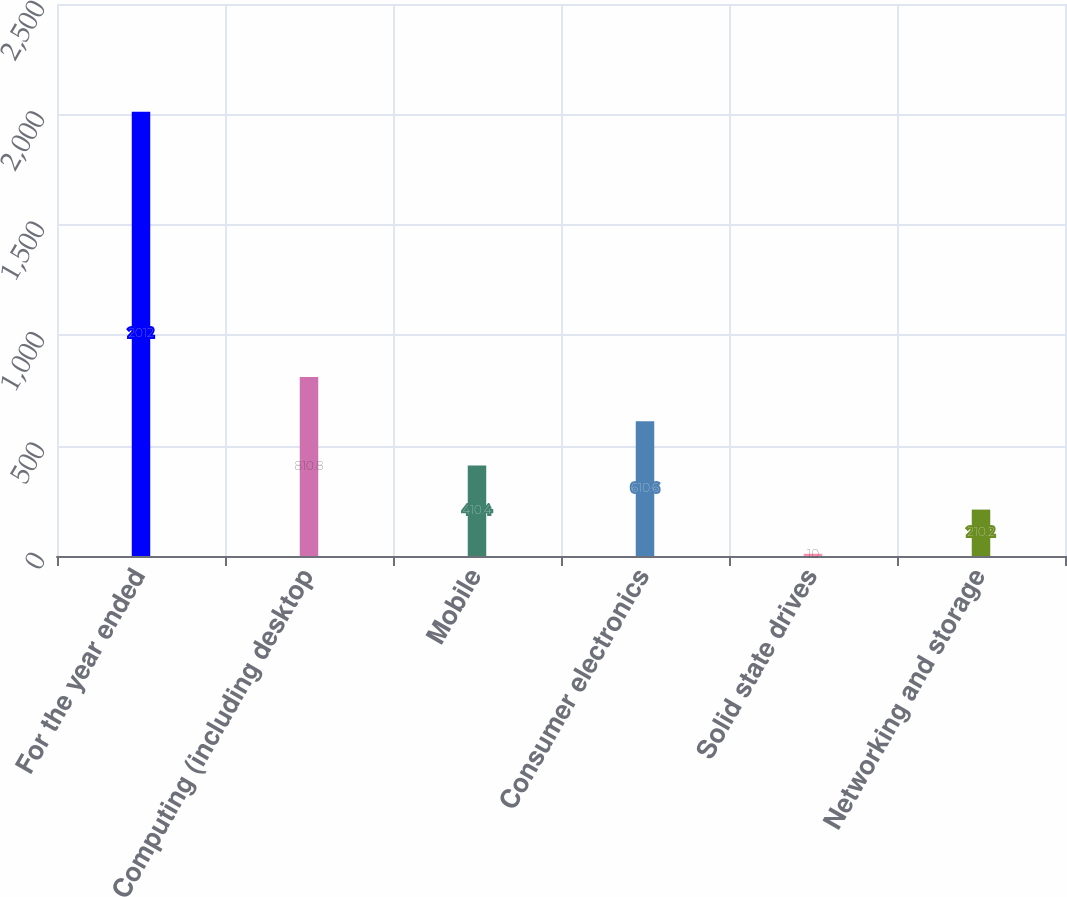<chart> <loc_0><loc_0><loc_500><loc_500><bar_chart><fcel>For the year ended<fcel>Computing (including desktop<fcel>Mobile<fcel>Consumer electronics<fcel>Solid state drives<fcel>Networking and storage<nl><fcel>2012<fcel>810.8<fcel>410.4<fcel>610.6<fcel>10<fcel>210.2<nl></chart> 